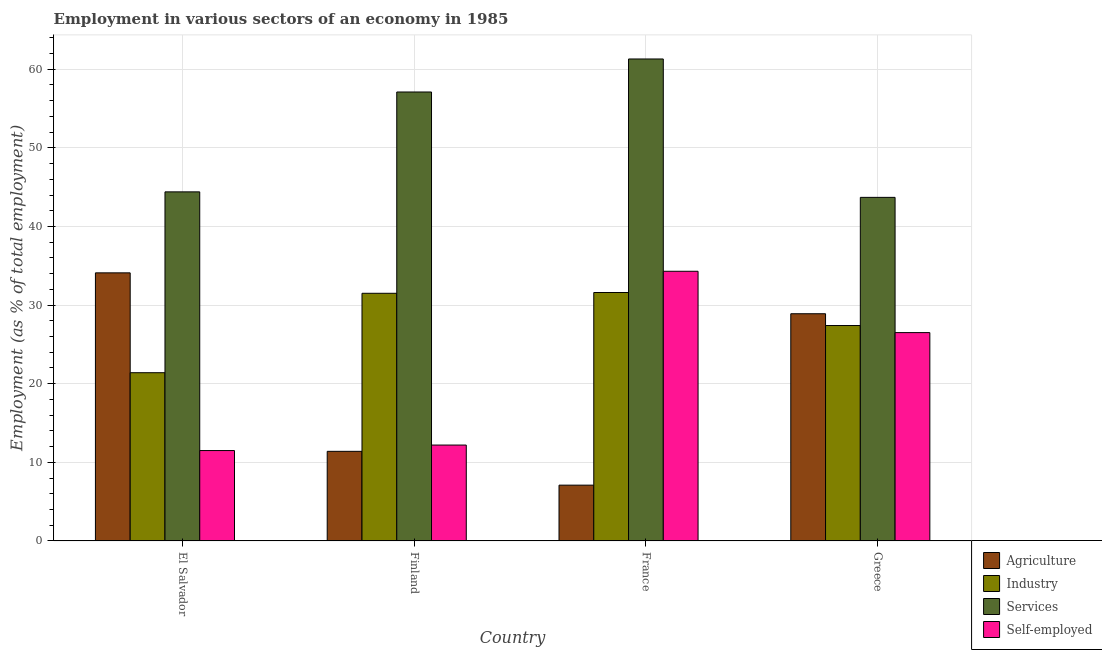How many different coloured bars are there?
Provide a short and direct response. 4. How many groups of bars are there?
Ensure brevity in your answer.  4. How many bars are there on the 3rd tick from the left?
Make the answer very short. 4. How many bars are there on the 3rd tick from the right?
Your response must be concise. 4. What is the label of the 4th group of bars from the left?
Your response must be concise. Greece. In how many cases, is the number of bars for a given country not equal to the number of legend labels?
Provide a short and direct response. 0. What is the percentage of workers in industry in Greece?
Offer a terse response. 27.4. Across all countries, what is the maximum percentage of workers in agriculture?
Provide a short and direct response. 34.1. In which country was the percentage of workers in services maximum?
Your answer should be very brief. France. In which country was the percentage of self employed workers minimum?
Your answer should be very brief. El Salvador. What is the total percentage of workers in industry in the graph?
Provide a short and direct response. 111.9. What is the difference between the percentage of workers in industry in El Salvador and that in France?
Make the answer very short. -10.2. What is the difference between the percentage of workers in industry in El Salvador and the percentage of workers in agriculture in France?
Offer a very short reply. 14.3. What is the average percentage of workers in agriculture per country?
Make the answer very short. 20.37. What is the difference between the percentage of workers in agriculture and percentage of workers in industry in Greece?
Offer a terse response. 1.5. In how many countries, is the percentage of self employed workers greater than 2 %?
Give a very brief answer. 4. What is the ratio of the percentage of self employed workers in Finland to that in Greece?
Give a very brief answer. 0.46. Is the percentage of self employed workers in Finland less than that in France?
Provide a short and direct response. Yes. What is the difference between the highest and the second highest percentage of self employed workers?
Your answer should be very brief. 7.8. What is the difference between the highest and the lowest percentage of workers in agriculture?
Ensure brevity in your answer.  27. What does the 2nd bar from the left in El Salvador represents?
Offer a very short reply. Industry. What does the 1st bar from the right in Finland represents?
Provide a short and direct response. Self-employed. Is it the case that in every country, the sum of the percentage of workers in agriculture and percentage of workers in industry is greater than the percentage of workers in services?
Your answer should be compact. No. How many bars are there?
Give a very brief answer. 16. What is the difference between two consecutive major ticks on the Y-axis?
Your answer should be very brief. 10. Does the graph contain grids?
Offer a very short reply. Yes. Where does the legend appear in the graph?
Give a very brief answer. Bottom right. What is the title of the graph?
Offer a very short reply. Employment in various sectors of an economy in 1985. Does "UNTA" appear as one of the legend labels in the graph?
Offer a terse response. No. What is the label or title of the Y-axis?
Keep it short and to the point. Employment (as % of total employment). What is the Employment (as % of total employment) in Agriculture in El Salvador?
Offer a very short reply. 34.1. What is the Employment (as % of total employment) in Industry in El Salvador?
Offer a terse response. 21.4. What is the Employment (as % of total employment) of Services in El Salvador?
Offer a very short reply. 44.4. What is the Employment (as % of total employment) in Agriculture in Finland?
Provide a succinct answer. 11.4. What is the Employment (as % of total employment) in Industry in Finland?
Make the answer very short. 31.5. What is the Employment (as % of total employment) of Services in Finland?
Your answer should be compact. 57.1. What is the Employment (as % of total employment) of Self-employed in Finland?
Provide a succinct answer. 12.2. What is the Employment (as % of total employment) in Agriculture in France?
Provide a short and direct response. 7.1. What is the Employment (as % of total employment) in Industry in France?
Ensure brevity in your answer.  31.6. What is the Employment (as % of total employment) of Services in France?
Make the answer very short. 61.3. What is the Employment (as % of total employment) of Self-employed in France?
Keep it short and to the point. 34.3. What is the Employment (as % of total employment) of Agriculture in Greece?
Provide a short and direct response. 28.9. What is the Employment (as % of total employment) of Industry in Greece?
Keep it short and to the point. 27.4. What is the Employment (as % of total employment) of Services in Greece?
Ensure brevity in your answer.  43.7. What is the Employment (as % of total employment) in Self-employed in Greece?
Ensure brevity in your answer.  26.5. Across all countries, what is the maximum Employment (as % of total employment) in Agriculture?
Provide a short and direct response. 34.1. Across all countries, what is the maximum Employment (as % of total employment) of Industry?
Provide a short and direct response. 31.6. Across all countries, what is the maximum Employment (as % of total employment) in Services?
Your answer should be compact. 61.3. Across all countries, what is the maximum Employment (as % of total employment) of Self-employed?
Keep it short and to the point. 34.3. Across all countries, what is the minimum Employment (as % of total employment) of Agriculture?
Offer a very short reply. 7.1. Across all countries, what is the minimum Employment (as % of total employment) of Industry?
Keep it short and to the point. 21.4. Across all countries, what is the minimum Employment (as % of total employment) of Services?
Your response must be concise. 43.7. What is the total Employment (as % of total employment) of Agriculture in the graph?
Your answer should be very brief. 81.5. What is the total Employment (as % of total employment) in Industry in the graph?
Offer a very short reply. 111.9. What is the total Employment (as % of total employment) in Services in the graph?
Ensure brevity in your answer.  206.5. What is the total Employment (as % of total employment) of Self-employed in the graph?
Your response must be concise. 84.5. What is the difference between the Employment (as % of total employment) in Agriculture in El Salvador and that in Finland?
Keep it short and to the point. 22.7. What is the difference between the Employment (as % of total employment) of Services in El Salvador and that in Finland?
Offer a terse response. -12.7. What is the difference between the Employment (as % of total employment) of Self-employed in El Salvador and that in Finland?
Make the answer very short. -0.7. What is the difference between the Employment (as % of total employment) in Industry in El Salvador and that in France?
Give a very brief answer. -10.2. What is the difference between the Employment (as % of total employment) in Services in El Salvador and that in France?
Your response must be concise. -16.9. What is the difference between the Employment (as % of total employment) of Self-employed in El Salvador and that in France?
Ensure brevity in your answer.  -22.8. What is the difference between the Employment (as % of total employment) of Agriculture in El Salvador and that in Greece?
Your answer should be very brief. 5.2. What is the difference between the Employment (as % of total employment) in Industry in El Salvador and that in Greece?
Your answer should be compact. -6. What is the difference between the Employment (as % of total employment) in Self-employed in El Salvador and that in Greece?
Your answer should be compact. -15. What is the difference between the Employment (as % of total employment) in Agriculture in Finland and that in France?
Provide a succinct answer. 4.3. What is the difference between the Employment (as % of total employment) in Services in Finland and that in France?
Provide a succinct answer. -4.2. What is the difference between the Employment (as % of total employment) in Self-employed in Finland and that in France?
Your answer should be compact. -22.1. What is the difference between the Employment (as % of total employment) of Agriculture in Finland and that in Greece?
Your answer should be compact. -17.5. What is the difference between the Employment (as % of total employment) in Self-employed in Finland and that in Greece?
Keep it short and to the point. -14.3. What is the difference between the Employment (as % of total employment) in Agriculture in France and that in Greece?
Provide a short and direct response. -21.8. What is the difference between the Employment (as % of total employment) of Agriculture in El Salvador and the Employment (as % of total employment) of Self-employed in Finland?
Offer a terse response. 21.9. What is the difference between the Employment (as % of total employment) of Industry in El Salvador and the Employment (as % of total employment) of Services in Finland?
Your response must be concise. -35.7. What is the difference between the Employment (as % of total employment) of Services in El Salvador and the Employment (as % of total employment) of Self-employed in Finland?
Ensure brevity in your answer.  32.2. What is the difference between the Employment (as % of total employment) in Agriculture in El Salvador and the Employment (as % of total employment) in Industry in France?
Ensure brevity in your answer.  2.5. What is the difference between the Employment (as % of total employment) of Agriculture in El Salvador and the Employment (as % of total employment) of Services in France?
Keep it short and to the point. -27.2. What is the difference between the Employment (as % of total employment) of Agriculture in El Salvador and the Employment (as % of total employment) of Self-employed in France?
Your answer should be very brief. -0.2. What is the difference between the Employment (as % of total employment) in Industry in El Salvador and the Employment (as % of total employment) in Services in France?
Provide a succinct answer. -39.9. What is the difference between the Employment (as % of total employment) in Industry in El Salvador and the Employment (as % of total employment) in Self-employed in France?
Your answer should be compact. -12.9. What is the difference between the Employment (as % of total employment) in Agriculture in El Salvador and the Employment (as % of total employment) in Industry in Greece?
Your answer should be very brief. 6.7. What is the difference between the Employment (as % of total employment) of Industry in El Salvador and the Employment (as % of total employment) of Services in Greece?
Provide a succinct answer. -22.3. What is the difference between the Employment (as % of total employment) of Services in El Salvador and the Employment (as % of total employment) of Self-employed in Greece?
Provide a succinct answer. 17.9. What is the difference between the Employment (as % of total employment) in Agriculture in Finland and the Employment (as % of total employment) in Industry in France?
Provide a short and direct response. -20.2. What is the difference between the Employment (as % of total employment) in Agriculture in Finland and the Employment (as % of total employment) in Services in France?
Keep it short and to the point. -49.9. What is the difference between the Employment (as % of total employment) of Agriculture in Finland and the Employment (as % of total employment) of Self-employed in France?
Keep it short and to the point. -22.9. What is the difference between the Employment (as % of total employment) in Industry in Finland and the Employment (as % of total employment) in Services in France?
Make the answer very short. -29.8. What is the difference between the Employment (as % of total employment) in Industry in Finland and the Employment (as % of total employment) in Self-employed in France?
Make the answer very short. -2.8. What is the difference between the Employment (as % of total employment) in Services in Finland and the Employment (as % of total employment) in Self-employed in France?
Offer a terse response. 22.8. What is the difference between the Employment (as % of total employment) of Agriculture in Finland and the Employment (as % of total employment) of Industry in Greece?
Provide a succinct answer. -16. What is the difference between the Employment (as % of total employment) in Agriculture in Finland and the Employment (as % of total employment) in Services in Greece?
Your response must be concise. -32.3. What is the difference between the Employment (as % of total employment) of Agriculture in Finland and the Employment (as % of total employment) of Self-employed in Greece?
Make the answer very short. -15.1. What is the difference between the Employment (as % of total employment) in Industry in Finland and the Employment (as % of total employment) in Services in Greece?
Your response must be concise. -12.2. What is the difference between the Employment (as % of total employment) in Industry in Finland and the Employment (as % of total employment) in Self-employed in Greece?
Your answer should be compact. 5. What is the difference between the Employment (as % of total employment) of Services in Finland and the Employment (as % of total employment) of Self-employed in Greece?
Offer a very short reply. 30.6. What is the difference between the Employment (as % of total employment) in Agriculture in France and the Employment (as % of total employment) in Industry in Greece?
Provide a short and direct response. -20.3. What is the difference between the Employment (as % of total employment) of Agriculture in France and the Employment (as % of total employment) of Services in Greece?
Make the answer very short. -36.6. What is the difference between the Employment (as % of total employment) of Agriculture in France and the Employment (as % of total employment) of Self-employed in Greece?
Make the answer very short. -19.4. What is the difference between the Employment (as % of total employment) in Industry in France and the Employment (as % of total employment) in Self-employed in Greece?
Ensure brevity in your answer.  5.1. What is the difference between the Employment (as % of total employment) in Services in France and the Employment (as % of total employment) in Self-employed in Greece?
Your answer should be compact. 34.8. What is the average Employment (as % of total employment) of Agriculture per country?
Your answer should be very brief. 20.38. What is the average Employment (as % of total employment) of Industry per country?
Your answer should be compact. 27.98. What is the average Employment (as % of total employment) of Services per country?
Keep it short and to the point. 51.62. What is the average Employment (as % of total employment) in Self-employed per country?
Offer a terse response. 21.12. What is the difference between the Employment (as % of total employment) of Agriculture and Employment (as % of total employment) of Services in El Salvador?
Your answer should be very brief. -10.3. What is the difference between the Employment (as % of total employment) of Agriculture and Employment (as % of total employment) of Self-employed in El Salvador?
Give a very brief answer. 22.6. What is the difference between the Employment (as % of total employment) of Industry and Employment (as % of total employment) of Self-employed in El Salvador?
Provide a short and direct response. 9.9. What is the difference between the Employment (as % of total employment) of Services and Employment (as % of total employment) of Self-employed in El Salvador?
Give a very brief answer. 32.9. What is the difference between the Employment (as % of total employment) in Agriculture and Employment (as % of total employment) in Industry in Finland?
Your response must be concise. -20.1. What is the difference between the Employment (as % of total employment) in Agriculture and Employment (as % of total employment) in Services in Finland?
Provide a short and direct response. -45.7. What is the difference between the Employment (as % of total employment) of Agriculture and Employment (as % of total employment) of Self-employed in Finland?
Provide a succinct answer. -0.8. What is the difference between the Employment (as % of total employment) of Industry and Employment (as % of total employment) of Services in Finland?
Keep it short and to the point. -25.6. What is the difference between the Employment (as % of total employment) of Industry and Employment (as % of total employment) of Self-employed in Finland?
Give a very brief answer. 19.3. What is the difference between the Employment (as % of total employment) in Services and Employment (as % of total employment) in Self-employed in Finland?
Offer a very short reply. 44.9. What is the difference between the Employment (as % of total employment) of Agriculture and Employment (as % of total employment) of Industry in France?
Provide a succinct answer. -24.5. What is the difference between the Employment (as % of total employment) in Agriculture and Employment (as % of total employment) in Services in France?
Make the answer very short. -54.2. What is the difference between the Employment (as % of total employment) of Agriculture and Employment (as % of total employment) of Self-employed in France?
Your response must be concise. -27.2. What is the difference between the Employment (as % of total employment) in Industry and Employment (as % of total employment) in Services in France?
Keep it short and to the point. -29.7. What is the difference between the Employment (as % of total employment) of Industry and Employment (as % of total employment) of Self-employed in France?
Give a very brief answer. -2.7. What is the difference between the Employment (as % of total employment) in Services and Employment (as % of total employment) in Self-employed in France?
Give a very brief answer. 27. What is the difference between the Employment (as % of total employment) in Agriculture and Employment (as % of total employment) in Services in Greece?
Your answer should be very brief. -14.8. What is the difference between the Employment (as % of total employment) in Industry and Employment (as % of total employment) in Services in Greece?
Provide a short and direct response. -16.3. What is the difference between the Employment (as % of total employment) of Industry and Employment (as % of total employment) of Self-employed in Greece?
Your answer should be compact. 0.9. What is the ratio of the Employment (as % of total employment) of Agriculture in El Salvador to that in Finland?
Offer a very short reply. 2.99. What is the ratio of the Employment (as % of total employment) of Industry in El Salvador to that in Finland?
Offer a terse response. 0.68. What is the ratio of the Employment (as % of total employment) of Services in El Salvador to that in Finland?
Your response must be concise. 0.78. What is the ratio of the Employment (as % of total employment) in Self-employed in El Salvador to that in Finland?
Offer a terse response. 0.94. What is the ratio of the Employment (as % of total employment) of Agriculture in El Salvador to that in France?
Your response must be concise. 4.8. What is the ratio of the Employment (as % of total employment) in Industry in El Salvador to that in France?
Offer a very short reply. 0.68. What is the ratio of the Employment (as % of total employment) of Services in El Salvador to that in France?
Provide a succinct answer. 0.72. What is the ratio of the Employment (as % of total employment) of Self-employed in El Salvador to that in France?
Keep it short and to the point. 0.34. What is the ratio of the Employment (as % of total employment) in Agriculture in El Salvador to that in Greece?
Your answer should be very brief. 1.18. What is the ratio of the Employment (as % of total employment) of Industry in El Salvador to that in Greece?
Provide a succinct answer. 0.78. What is the ratio of the Employment (as % of total employment) of Self-employed in El Salvador to that in Greece?
Offer a very short reply. 0.43. What is the ratio of the Employment (as % of total employment) in Agriculture in Finland to that in France?
Provide a succinct answer. 1.61. What is the ratio of the Employment (as % of total employment) of Services in Finland to that in France?
Ensure brevity in your answer.  0.93. What is the ratio of the Employment (as % of total employment) in Self-employed in Finland to that in France?
Make the answer very short. 0.36. What is the ratio of the Employment (as % of total employment) in Agriculture in Finland to that in Greece?
Ensure brevity in your answer.  0.39. What is the ratio of the Employment (as % of total employment) in Industry in Finland to that in Greece?
Make the answer very short. 1.15. What is the ratio of the Employment (as % of total employment) of Services in Finland to that in Greece?
Offer a terse response. 1.31. What is the ratio of the Employment (as % of total employment) of Self-employed in Finland to that in Greece?
Ensure brevity in your answer.  0.46. What is the ratio of the Employment (as % of total employment) in Agriculture in France to that in Greece?
Provide a short and direct response. 0.25. What is the ratio of the Employment (as % of total employment) in Industry in France to that in Greece?
Offer a terse response. 1.15. What is the ratio of the Employment (as % of total employment) in Services in France to that in Greece?
Offer a very short reply. 1.4. What is the ratio of the Employment (as % of total employment) in Self-employed in France to that in Greece?
Your answer should be compact. 1.29. What is the difference between the highest and the second highest Employment (as % of total employment) of Agriculture?
Make the answer very short. 5.2. What is the difference between the highest and the second highest Employment (as % of total employment) of Self-employed?
Provide a short and direct response. 7.8. What is the difference between the highest and the lowest Employment (as % of total employment) of Agriculture?
Provide a short and direct response. 27. What is the difference between the highest and the lowest Employment (as % of total employment) in Industry?
Your response must be concise. 10.2. What is the difference between the highest and the lowest Employment (as % of total employment) in Services?
Provide a short and direct response. 17.6. What is the difference between the highest and the lowest Employment (as % of total employment) of Self-employed?
Your response must be concise. 22.8. 